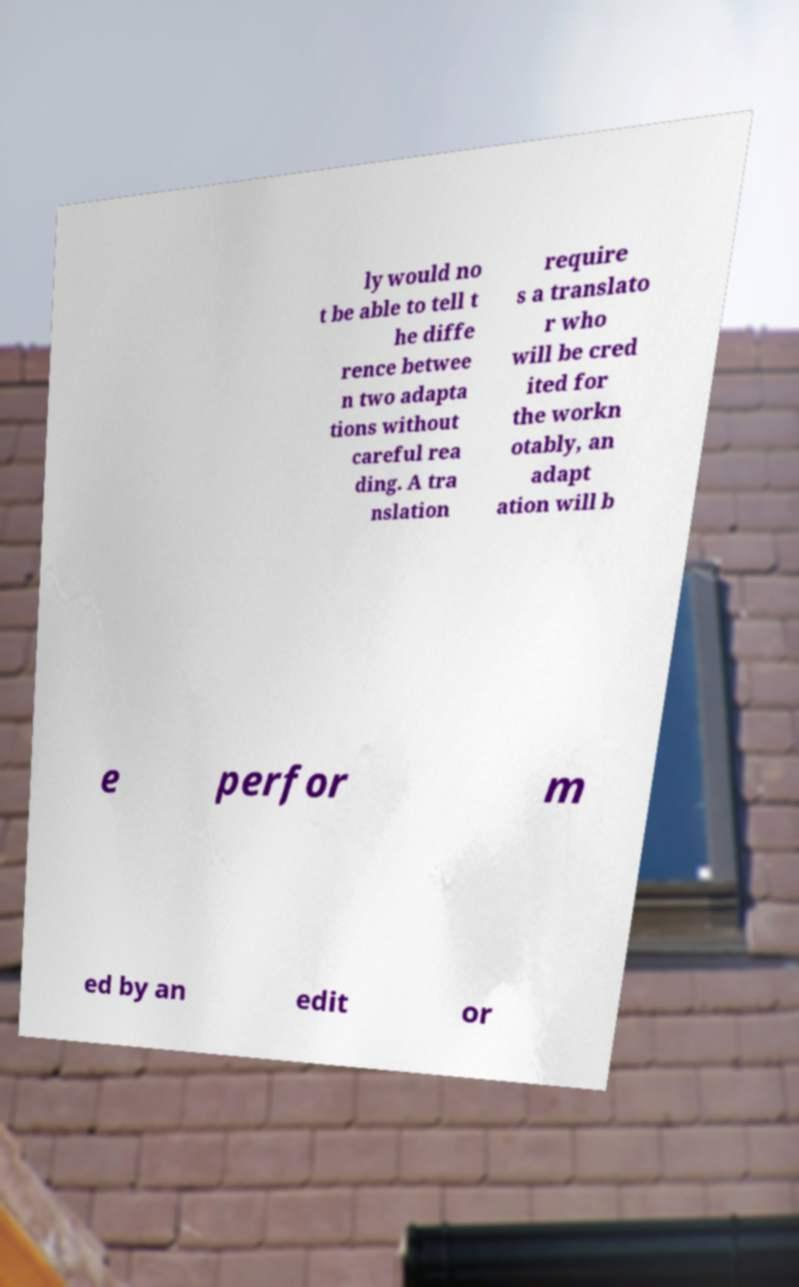For documentation purposes, I need the text within this image transcribed. Could you provide that? ly would no t be able to tell t he diffe rence betwee n two adapta tions without careful rea ding. A tra nslation require s a translato r who will be cred ited for the workn otably, an adapt ation will b e perfor m ed by an edit or 